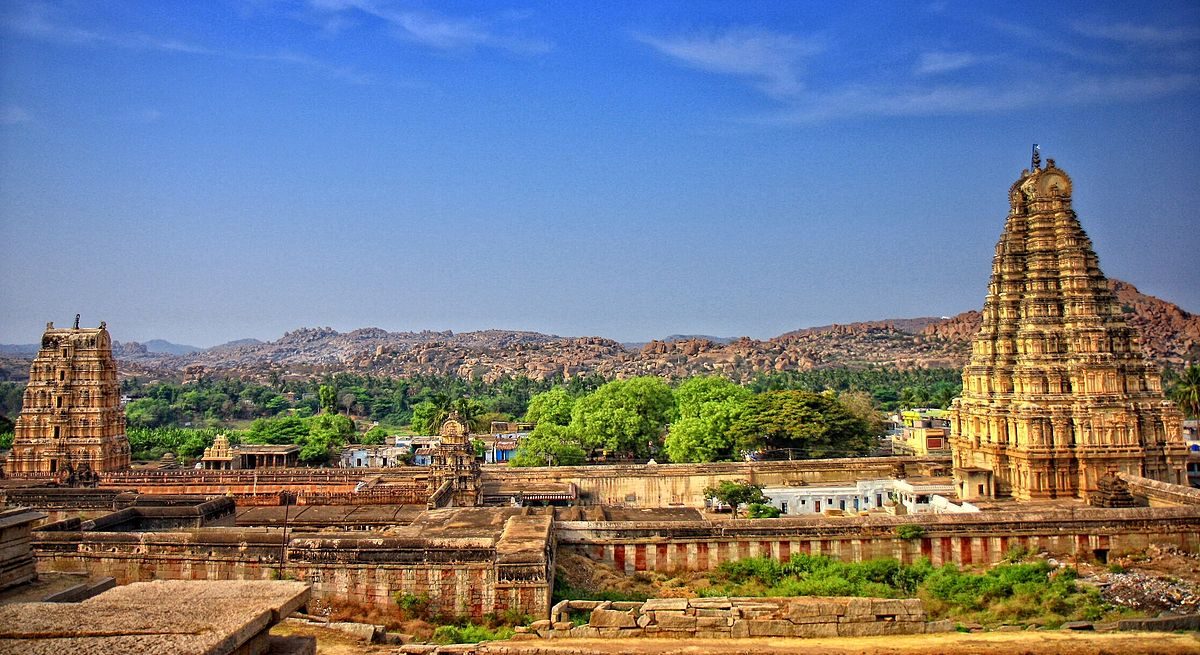What can you tell me about the historical significance of this temple? Virupaksha Temple, a part of the Group of Monuments at Hampi, is a UNESCO World Heritage site with immense historical significance. Originating in the 7th century, the temple was built by the Chalukyas and later developed by the Vijayanagara Empire. It has been in uninterrupted worship since its inception, making it one of the oldest functioning temples in India. The temple is dedicated to Virupaksha, an aspect of Lord Shiva, and is a principal center of pilgrimage. It played a pivotal role in the religious, cultural, and economic life of the region. 